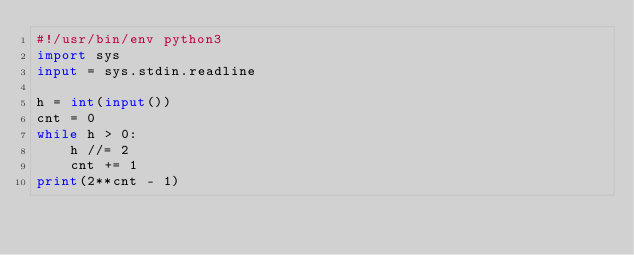<code> <loc_0><loc_0><loc_500><loc_500><_Python_>#!/usr/bin/env python3
import sys
input = sys.stdin.readline

h = int(input())
cnt = 0
while h > 0:
    h //= 2
    cnt += 1
print(2**cnt - 1)</code> 